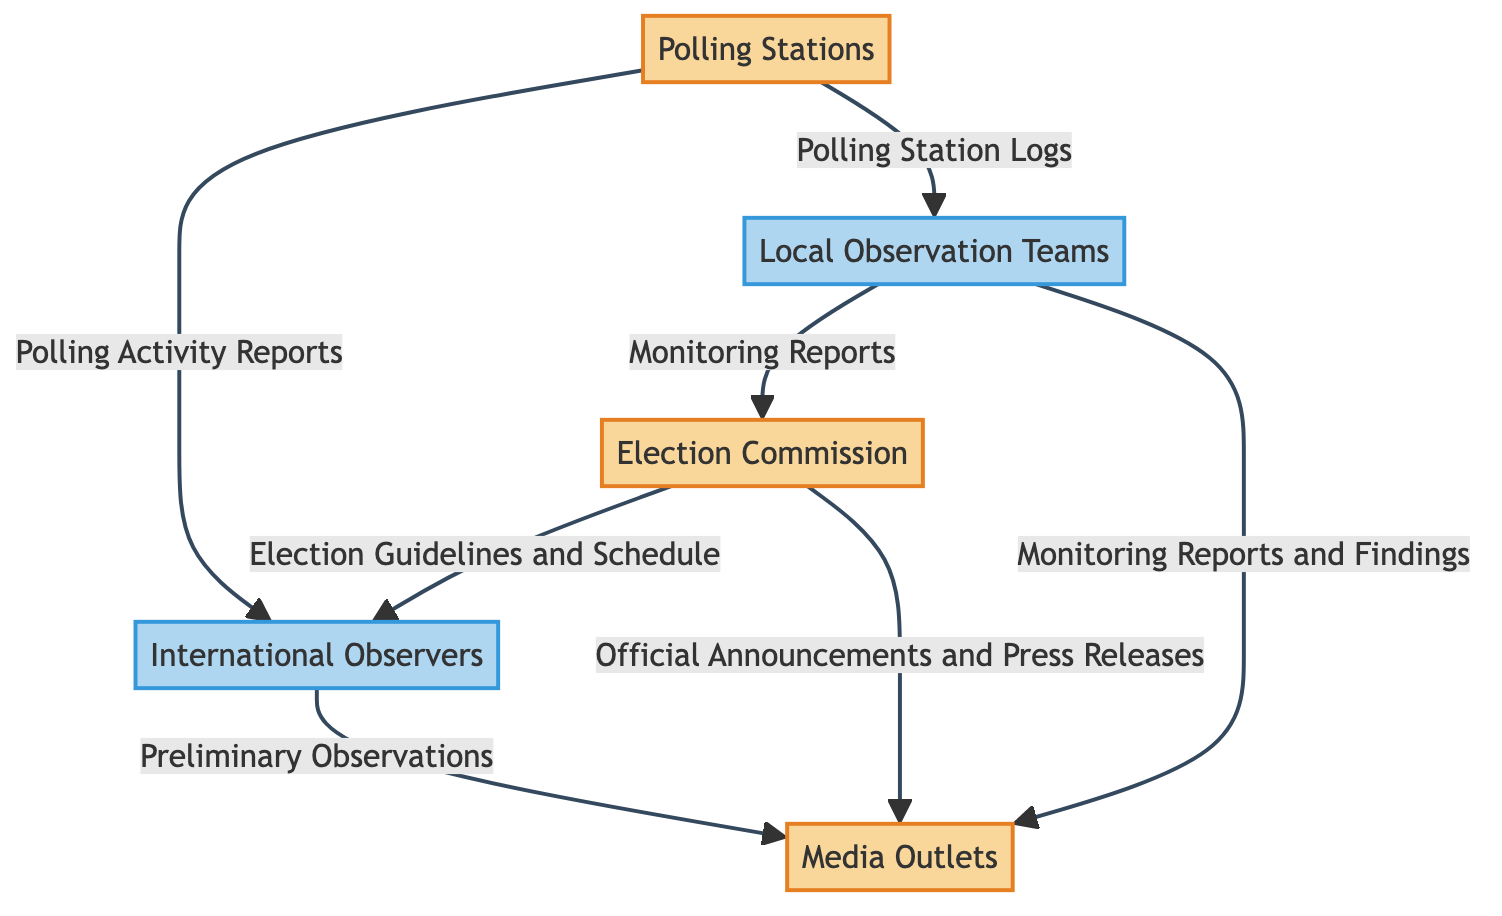What are the two external entities involved in the election monitoring process? The diagram lists "Election Commission" and "Polling Stations" as the two external entities engaged in the election monitoring process.
Answer: Election Commission, Polling Stations How many processes are shown in the diagram? The diagram presents three processes: "International Observers," "Local Observation Teams," and "Media Outlets." By counting these processes, we arrive at the number.
Answer: 3 What type of data flows from the Polling Stations to the International Observers? According to the diagram, the data flowing from "Polling Stations" to "International Observers" is the "Polling Activity Reports." This specific flow indicates the information shared.
Answer: Polling Activity Reports Which entity provides "Official Announcements and Press Releases" to Media Outlets? The source of "Official Announcements and Press Releases" to "Media Outlets" is the "Election Commission." This is explicitly stated in the diagram.
Answer: Election Commission What is the relationship between Local Observation Teams and the Election Commission? The relationship is established through data flow, where "Local Observation Teams" send "Monitoring Reports" to the "Election Commission." This flow defines the interaction between these two entities.
Answer: Monitoring Reports How many data flows are there from the Local Observation Teams to Media Outlets? The diagram shows two distinct data flows: "Monitoring Reports and Findings." Counting these indicates the total number of flows.
Answer: 2 What kind of reports do Polling Stations provide to Local Observation Teams? The specific type of report that "Polling Stations" provide to "Local Observation Teams" is referred to as "Polling Station Logs." This is directly indicated in the diagram.
Answer: Polling Station Logs Who monitors the election process to ensure compliance with international standards? The "International Observers" are designated to monitor the election and ensure adherence to international standards, as described in the diagram.
Answer: International Observers What type of data do International Observers receive from the Election Commission? The "Election Guidelines and Schedule" are the specific type of data that "International Observers" receive from the "Election Commission." This is clearly delineated in the diagram.
Answer: Election Guidelines and Schedule 